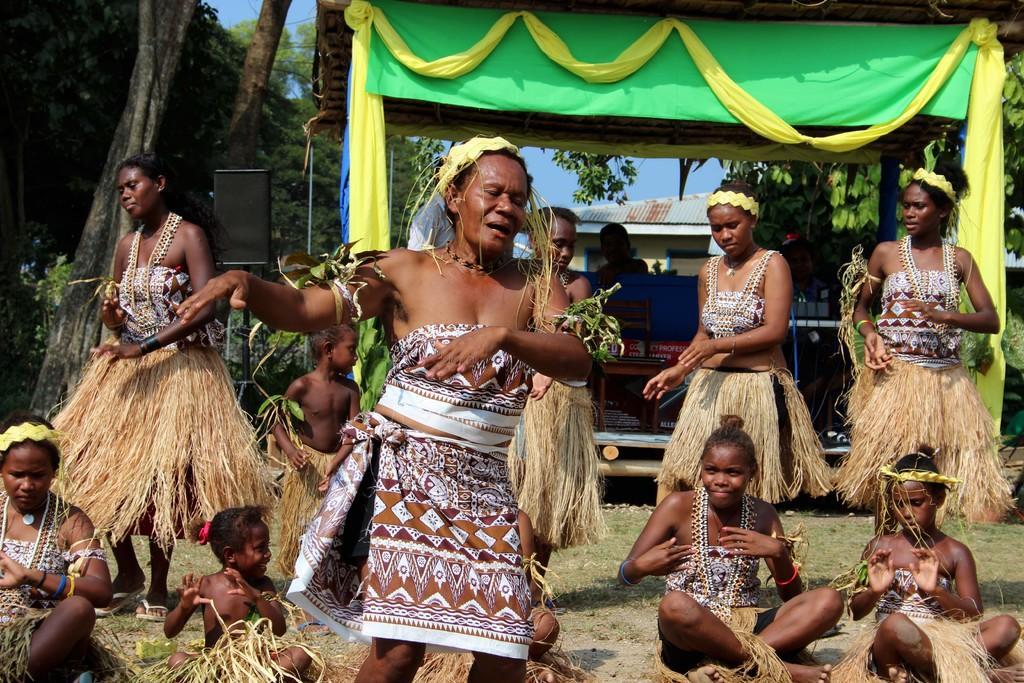Could you give a brief overview of what you see in this image? In this picture, we see women wearing costumes are dancing. Behind them, we see a table on which red box is placed. We see a yellow curtain and a green color sheet. In the background, there are trees and buildings. 